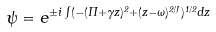Convert formula to latex. <formula><loc_0><loc_0><loc_500><loc_500>\psi = e ^ { \pm i \int ( - ( \Pi + \gamma z ) ^ { 2 } + ( z - \omega ) ^ { 2 / J } ) ^ { 1 / 2 } d z }</formula> 